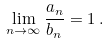<formula> <loc_0><loc_0><loc_500><loc_500>\lim _ { n \to \infty } \frac { a _ { n } } { b _ { n } } = 1 \, .</formula> 